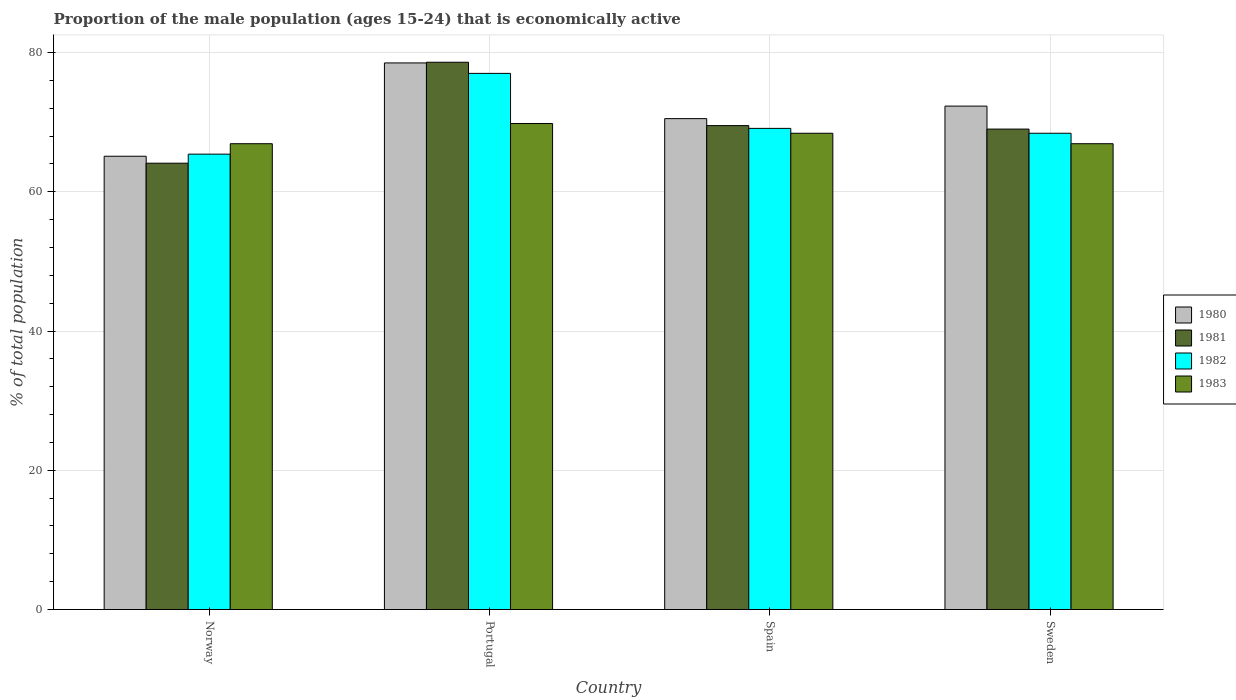How many different coloured bars are there?
Provide a short and direct response. 4. How many groups of bars are there?
Ensure brevity in your answer.  4. How many bars are there on the 1st tick from the right?
Provide a succinct answer. 4. In how many cases, is the number of bars for a given country not equal to the number of legend labels?
Your response must be concise. 0. What is the proportion of the male population that is economically active in 1982 in Norway?
Keep it short and to the point. 65.4. Across all countries, what is the maximum proportion of the male population that is economically active in 1980?
Give a very brief answer. 78.5. Across all countries, what is the minimum proportion of the male population that is economically active in 1980?
Your answer should be compact. 65.1. What is the total proportion of the male population that is economically active in 1982 in the graph?
Ensure brevity in your answer.  279.9. What is the difference between the proportion of the male population that is economically active in 1982 in Portugal and that in Spain?
Give a very brief answer. 7.9. What is the difference between the proportion of the male population that is economically active in 1980 in Portugal and the proportion of the male population that is economically active in 1981 in Norway?
Offer a very short reply. 14.4. What is the average proportion of the male population that is economically active in 1981 per country?
Your response must be concise. 70.3. What is the difference between the proportion of the male population that is economically active of/in 1981 and proportion of the male population that is economically active of/in 1980 in Norway?
Offer a very short reply. -1. In how many countries, is the proportion of the male population that is economically active in 1981 greater than 36 %?
Offer a very short reply. 4. What is the ratio of the proportion of the male population that is economically active in 1983 in Spain to that in Sweden?
Your response must be concise. 1.02. Is the proportion of the male population that is economically active in 1980 in Norway less than that in Sweden?
Your answer should be very brief. Yes. Is the difference between the proportion of the male population that is economically active in 1981 in Norway and Spain greater than the difference between the proportion of the male population that is economically active in 1980 in Norway and Spain?
Your answer should be very brief. No. What is the difference between the highest and the lowest proportion of the male population that is economically active in 1982?
Make the answer very short. 11.6. In how many countries, is the proportion of the male population that is economically active in 1983 greater than the average proportion of the male population that is economically active in 1983 taken over all countries?
Offer a terse response. 2. Is the sum of the proportion of the male population that is economically active in 1983 in Norway and Spain greater than the maximum proportion of the male population that is economically active in 1981 across all countries?
Keep it short and to the point. Yes. Is it the case that in every country, the sum of the proportion of the male population that is economically active in 1981 and proportion of the male population that is economically active in 1980 is greater than the proportion of the male population that is economically active in 1983?
Offer a terse response. Yes. Are all the bars in the graph horizontal?
Your answer should be very brief. No. How many countries are there in the graph?
Your answer should be compact. 4. What is the difference between two consecutive major ticks on the Y-axis?
Provide a short and direct response. 20. Are the values on the major ticks of Y-axis written in scientific E-notation?
Provide a succinct answer. No. Does the graph contain grids?
Give a very brief answer. Yes. How are the legend labels stacked?
Provide a short and direct response. Vertical. What is the title of the graph?
Provide a succinct answer. Proportion of the male population (ages 15-24) that is economically active. Does "1969" appear as one of the legend labels in the graph?
Make the answer very short. No. What is the label or title of the X-axis?
Provide a short and direct response. Country. What is the label or title of the Y-axis?
Your answer should be very brief. % of total population. What is the % of total population of 1980 in Norway?
Provide a succinct answer. 65.1. What is the % of total population in 1981 in Norway?
Your response must be concise. 64.1. What is the % of total population in 1982 in Norway?
Provide a succinct answer. 65.4. What is the % of total population in 1983 in Norway?
Ensure brevity in your answer.  66.9. What is the % of total population of 1980 in Portugal?
Offer a very short reply. 78.5. What is the % of total population of 1981 in Portugal?
Offer a terse response. 78.6. What is the % of total population of 1982 in Portugal?
Your response must be concise. 77. What is the % of total population of 1983 in Portugal?
Your answer should be very brief. 69.8. What is the % of total population of 1980 in Spain?
Your response must be concise. 70.5. What is the % of total population of 1981 in Spain?
Provide a short and direct response. 69.5. What is the % of total population of 1982 in Spain?
Offer a terse response. 69.1. What is the % of total population in 1983 in Spain?
Give a very brief answer. 68.4. What is the % of total population in 1980 in Sweden?
Ensure brevity in your answer.  72.3. What is the % of total population of 1981 in Sweden?
Give a very brief answer. 69. What is the % of total population of 1982 in Sweden?
Provide a succinct answer. 68.4. What is the % of total population in 1983 in Sweden?
Ensure brevity in your answer.  66.9. Across all countries, what is the maximum % of total population of 1980?
Ensure brevity in your answer.  78.5. Across all countries, what is the maximum % of total population in 1981?
Provide a short and direct response. 78.6. Across all countries, what is the maximum % of total population of 1982?
Ensure brevity in your answer.  77. Across all countries, what is the maximum % of total population in 1983?
Offer a very short reply. 69.8. Across all countries, what is the minimum % of total population in 1980?
Give a very brief answer. 65.1. Across all countries, what is the minimum % of total population in 1981?
Your answer should be compact. 64.1. Across all countries, what is the minimum % of total population of 1982?
Ensure brevity in your answer.  65.4. Across all countries, what is the minimum % of total population in 1983?
Give a very brief answer. 66.9. What is the total % of total population in 1980 in the graph?
Offer a very short reply. 286.4. What is the total % of total population of 1981 in the graph?
Give a very brief answer. 281.2. What is the total % of total population of 1982 in the graph?
Your answer should be very brief. 279.9. What is the total % of total population in 1983 in the graph?
Your answer should be compact. 272. What is the difference between the % of total population of 1982 in Norway and that in Portugal?
Ensure brevity in your answer.  -11.6. What is the difference between the % of total population of 1982 in Norway and that in Spain?
Give a very brief answer. -3.7. What is the difference between the % of total population of 1983 in Norway and that in Spain?
Ensure brevity in your answer.  -1.5. What is the difference between the % of total population of 1980 in Norway and that in Sweden?
Offer a terse response. -7.2. What is the difference between the % of total population in 1983 in Norway and that in Sweden?
Keep it short and to the point. 0. What is the difference between the % of total population of 1981 in Portugal and that in Spain?
Keep it short and to the point. 9.1. What is the difference between the % of total population of 1983 in Portugal and that in Spain?
Your response must be concise. 1.4. What is the difference between the % of total population of 1983 in Portugal and that in Sweden?
Keep it short and to the point. 2.9. What is the difference between the % of total population of 1981 in Spain and that in Sweden?
Offer a terse response. 0.5. What is the difference between the % of total population of 1982 in Spain and that in Sweden?
Offer a terse response. 0.7. What is the difference between the % of total population in 1980 in Norway and the % of total population in 1981 in Portugal?
Provide a short and direct response. -13.5. What is the difference between the % of total population in 1981 in Norway and the % of total population in 1982 in Portugal?
Your answer should be compact. -12.9. What is the difference between the % of total population of 1982 in Norway and the % of total population of 1983 in Portugal?
Your response must be concise. -4.4. What is the difference between the % of total population in 1980 in Norway and the % of total population in 1981 in Spain?
Offer a terse response. -4.4. What is the difference between the % of total population in 1980 in Norway and the % of total population in 1983 in Spain?
Provide a short and direct response. -3.3. What is the difference between the % of total population of 1981 in Norway and the % of total population of 1982 in Spain?
Provide a succinct answer. -5. What is the difference between the % of total population of 1980 in Norway and the % of total population of 1981 in Sweden?
Offer a very short reply. -3.9. What is the difference between the % of total population in 1980 in Norway and the % of total population in 1982 in Sweden?
Your answer should be very brief. -3.3. What is the difference between the % of total population of 1981 in Norway and the % of total population of 1983 in Sweden?
Provide a succinct answer. -2.8. What is the difference between the % of total population in 1982 in Norway and the % of total population in 1983 in Sweden?
Provide a succinct answer. -1.5. What is the difference between the % of total population of 1980 in Portugal and the % of total population of 1981 in Spain?
Your response must be concise. 9. What is the difference between the % of total population in 1980 in Portugal and the % of total population in 1982 in Spain?
Offer a very short reply. 9.4. What is the difference between the % of total population in 1980 in Portugal and the % of total population in 1983 in Sweden?
Ensure brevity in your answer.  11.6. What is the difference between the % of total population in 1981 in Portugal and the % of total population in 1982 in Sweden?
Ensure brevity in your answer.  10.2. What is the difference between the % of total population in 1981 in Portugal and the % of total population in 1983 in Sweden?
Give a very brief answer. 11.7. What is the difference between the % of total population in 1982 in Portugal and the % of total population in 1983 in Sweden?
Give a very brief answer. 10.1. What is the difference between the % of total population in 1980 in Spain and the % of total population in 1981 in Sweden?
Make the answer very short. 1.5. What is the difference between the % of total population of 1980 in Spain and the % of total population of 1982 in Sweden?
Keep it short and to the point. 2.1. What is the difference between the % of total population in 1980 in Spain and the % of total population in 1983 in Sweden?
Ensure brevity in your answer.  3.6. What is the difference between the % of total population in 1981 in Spain and the % of total population in 1982 in Sweden?
Offer a very short reply. 1.1. What is the average % of total population of 1980 per country?
Ensure brevity in your answer.  71.6. What is the average % of total population of 1981 per country?
Your answer should be compact. 70.3. What is the average % of total population in 1982 per country?
Keep it short and to the point. 69.97. What is the difference between the % of total population in 1980 and % of total population in 1983 in Norway?
Provide a short and direct response. -1.8. What is the difference between the % of total population in 1981 and % of total population in 1982 in Norway?
Offer a terse response. -1.3. What is the difference between the % of total population in 1981 and % of total population in 1983 in Norway?
Ensure brevity in your answer.  -2.8. What is the difference between the % of total population in 1982 and % of total population in 1983 in Norway?
Give a very brief answer. -1.5. What is the difference between the % of total population of 1981 and % of total population of 1983 in Portugal?
Provide a succinct answer. 8.8. What is the difference between the % of total population in 1980 and % of total population in 1981 in Spain?
Ensure brevity in your answer.  1. What is the difference between the % of total population of 1980 and % of total population of 1982 in Sweden?
Give a very brief answer. 3.9. What is the difference between the % of total population in 1980 and % of total population in 1983 in Sweden?
Offer a very short reply. 5.4. What is the difference between the % of total population of 1981 and % of total population of 1982 in Sweden?
Ensure brevity in your answer.  0.6. What is the difference between the % of total population in 1982 and % of total population in 1983 in Sweden?
Your answer should be compact. 1.5. What is the ratio of the % of total population in 1980 in Norway to that in Portugal?
Offer a very short reply. 0.83. What is the ratio of the % of total population in 1981 in Norway to that in Portugal?
Make the answer very short. 0.82. What is the ratio of the % of total population in 1982 in Norway to that in Portugal?
Offer a terse response. 0.85. What is the ratio of the % of total population of 1983 in Norway to that in Portugal?
Provide a succinct answer. 0.96. What is the ratio of the % of total population in 1980 in Norway to that in Spain?
Your response must be concise. 0.92. What is the ratio of the % of total population in 1981 in Norway to that in Spain?
Your response must be concise. 0.92. What is the ratio of the % of total population in 1982 in Norway to that in Spain?
Offer a very short reply. 0.95. What is the ratio of the % of total population of 1983 in Norway to that in Spain?
Your response must be concise. 0.98. What is the ratio of the % of total population in 1980 in Norway to that in Sweden?
Provide a succinct answer. 0.9. What is the ratio of the % of total population in 1981 in Norway to that in Sweden?
Offer a terse response. 0.93. What is the ratio of the % of total population in 1982 in Norway to that in Sweden?
Your answer should be very brief. 0.96. What is the ratio of the % of total population in 1983 in Norway to that in Sweden?
Your answer should be very brief. 1. What is the ratio of the % of total population in 1980 in Portugal to that in Spain?
Ensure brevity in your answer.  1.11. What is the ratio of the % of total population in 1981 in Portugal to that in Spain?
Make the answer very short. 1.13. What is the ratio of the % of total population of 1982 in Portugal to that in Spain?
Provide a short and direct response. 1.11. What is the ratio of the % of total population in 1983 in Portugal to that in Spain?
Ensure brevity in your answer.  1.02. What is the ratio of the % of total population in 1980 in Portugal to that in Sweden?
Make the answer very short. 1.09. What is the ratio of the % of total population of 1981 in Portugal to that in Sweden?
Ensure brevity in your answer.  1.14. What is the ratio of the % of total population of 1982 in Portugal to that in Sweden?
Your response must be concise. 1.13. What is the ratio of the % of total population of 1983 in Portugal to that in Sweden?
Keep it short and to the point. 1.04. What is the ratio of the % of total population of 1980 in Spain to that in Sweden?
Offer a terse response. 0.98. What is the ratio of the % of total population in 1981 in Spain to that in Sweden?
Give a very brief answer. 1.01. What is the ratio of the % of total population of 1982 in Spain to that in Sweden?
Make the answer very short. 1.01. What is the ratio of the % of total population in 1983 in Spain to that in Sweden?
Ensure brevity in your answer.  1.02. What is the difference between the highest and the second highest % of total population of 1981?
Your answer should be compact. 9.1. What is the difference between the highest and the lowest % of total population of 1982?
Provide a succinct answer. 11.6. What is the difference between the highest and the lowest % of total population of 1983?
Offer a very short reply. 2.9. 